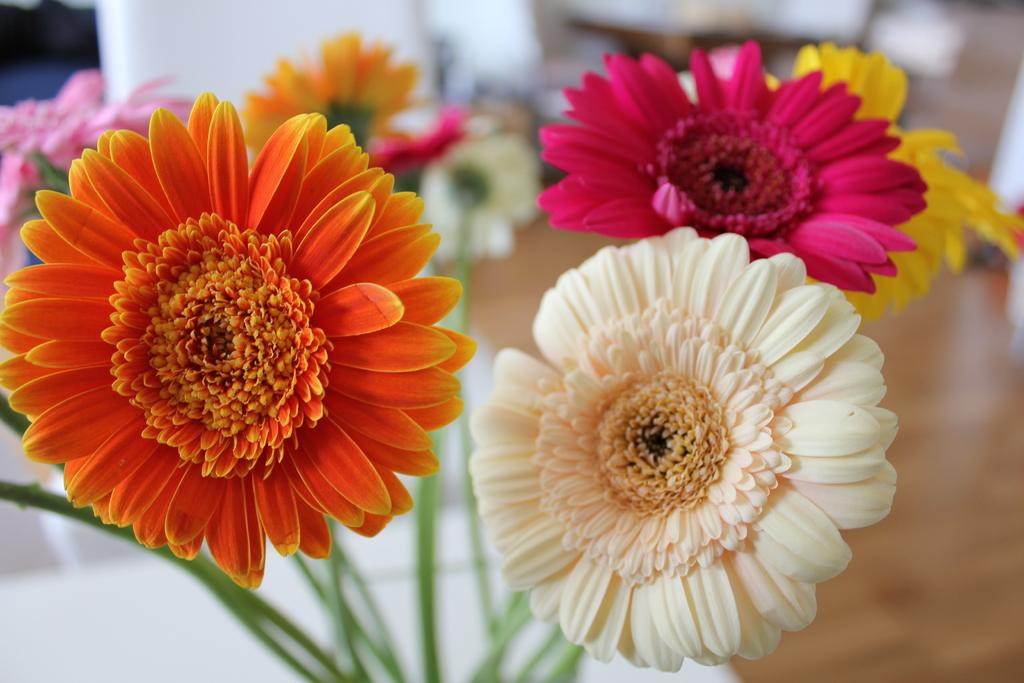What type of plants are in the image? There are flowers in the image. How many colors can be seen among the flowers? The flowers have different colors. Where are the flowers located in the image? The flowers are in the middle of the image. Can you tell me how many cacti are in the image? There are no cacti present in the image; it features flowers. What type of bird can be seen perched on the flowers in the image? There are no birds, specifically robins, present in the image. 